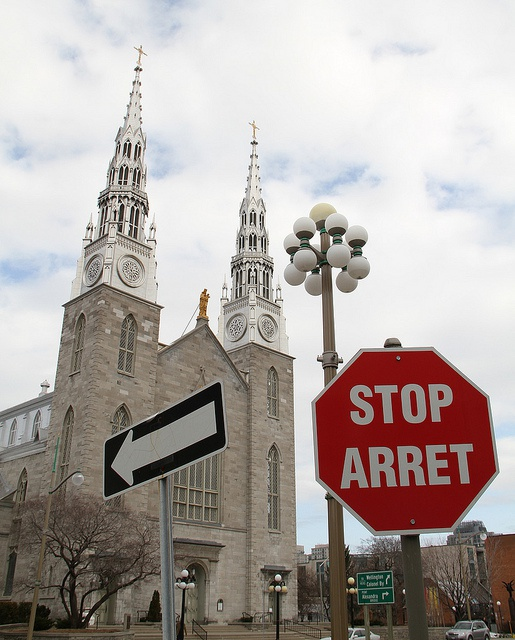Describe the objects in this image and their specific colors. I can see stop sign in white, maroon, and gray tones, car in white, gray, black, and darkgray tones, car in white, darkgray, gray, black, and teal tones, people in white, black, maroon, gray, and darkgreen tones, and people in white, black, gray, maroon, and darkgreen tones in this image. 